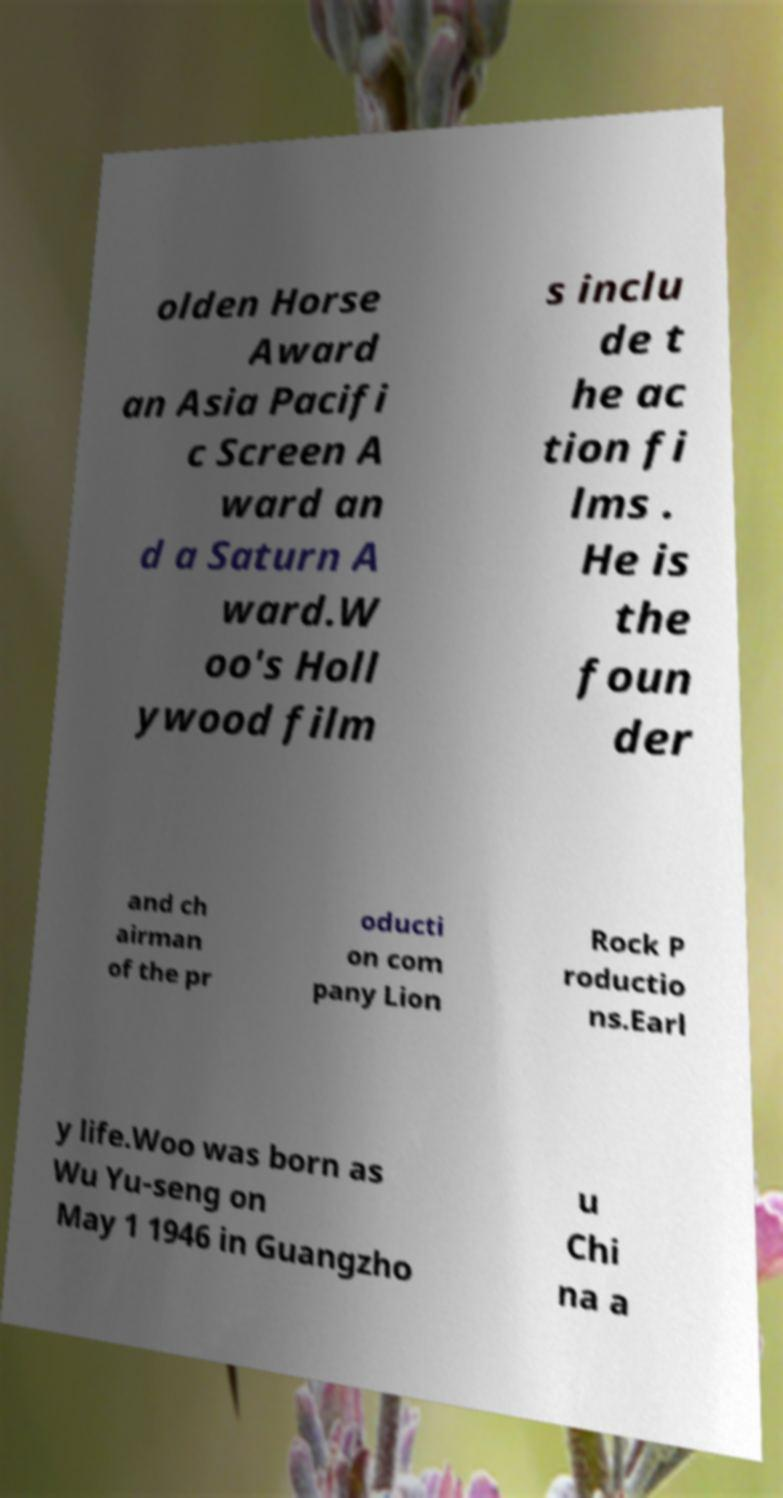Can you accurately transcribe the text from the provided image for me? olden Horse Award an Asia Pacifi c Screen A ward an d a Saturn A ward.W oo's Holl ywood film s inclu de t he ac tion fi lms . He is the foun der and ch airman of the pr oducti on com pany Lion Rock P roductio ns.Earl y life.Woo was born as Wu Yu-seng on May 1 1946 in Guangzho u Chi na a 